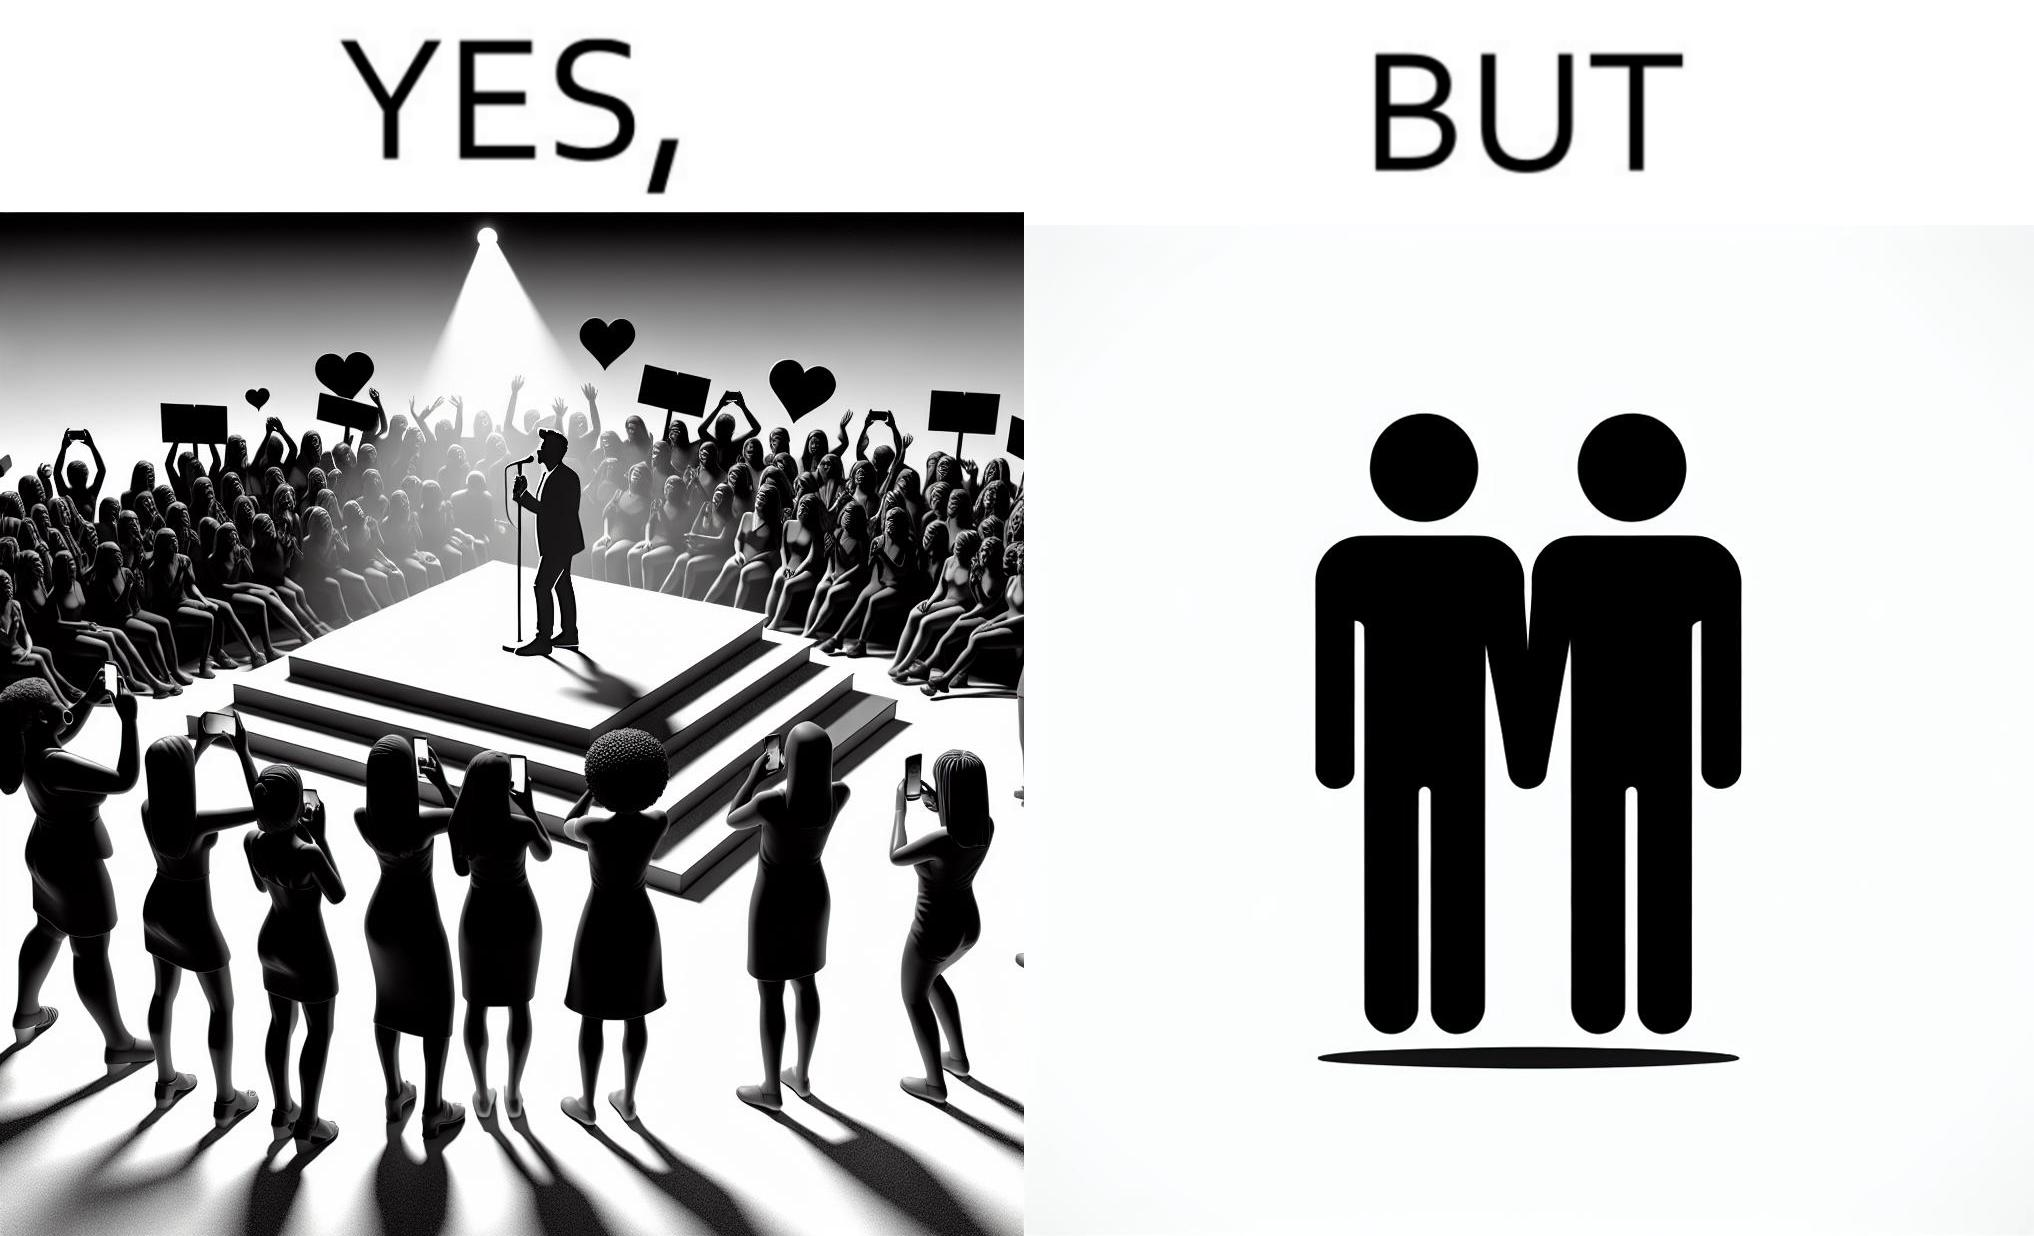What do you see in each half of this image? In the left part of the image: The person shows a man singing on a platform under a spotlight. There are several girls around the platform enjoying his singing and cheering for him. A few girls are taking his photos using their phone and a few also have a poster with heart drawn on it. In the right part of the image: The image shows two men holding hands. 